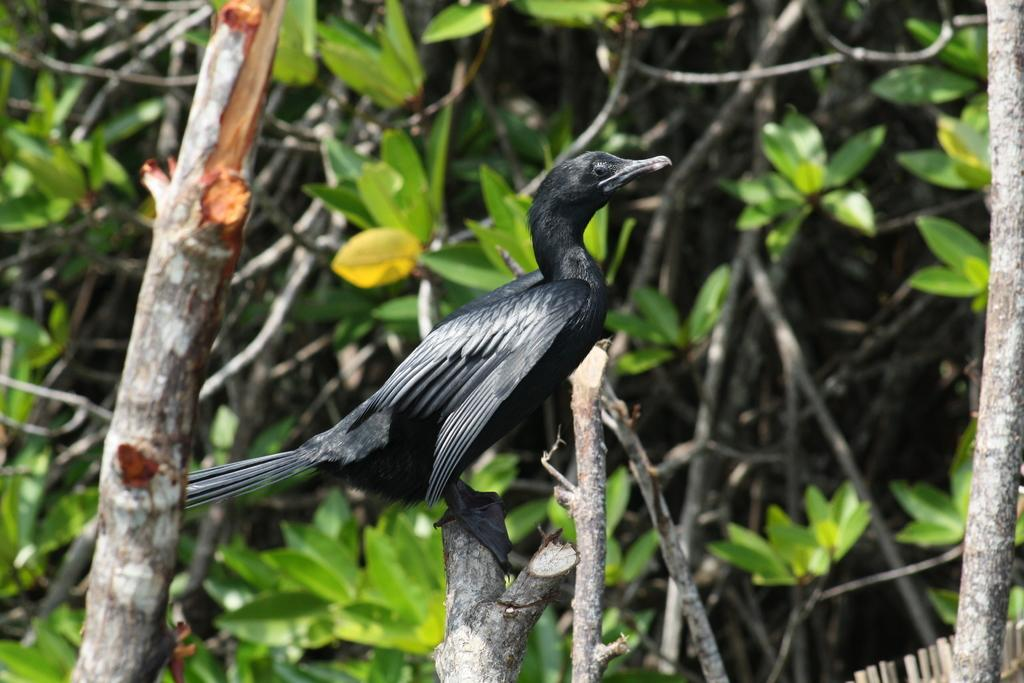What type of animal is in the image? There is a black bird in the image. Where is the bird located? The bird is sitting on a branch of a tree. What else can be seen in the image besides the bird? There are other plants visible in the image. Can you tell me how much credit the bird has in the image? There is no mention of credit or any financial aspect in the image; it features a black bird sitting on a tree branch. 